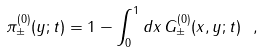<formula> <loc_0><loc_0><loc_500><loc_500>\pi _ { \pm } ^ { ( 0 ) } ( y ; t ) = 1 - \int _ { 0 } ^ { 1 } d x \, G _ { \pm } ^ { ( 0 ) } ( x , y ; t ) \ ,</formula> 